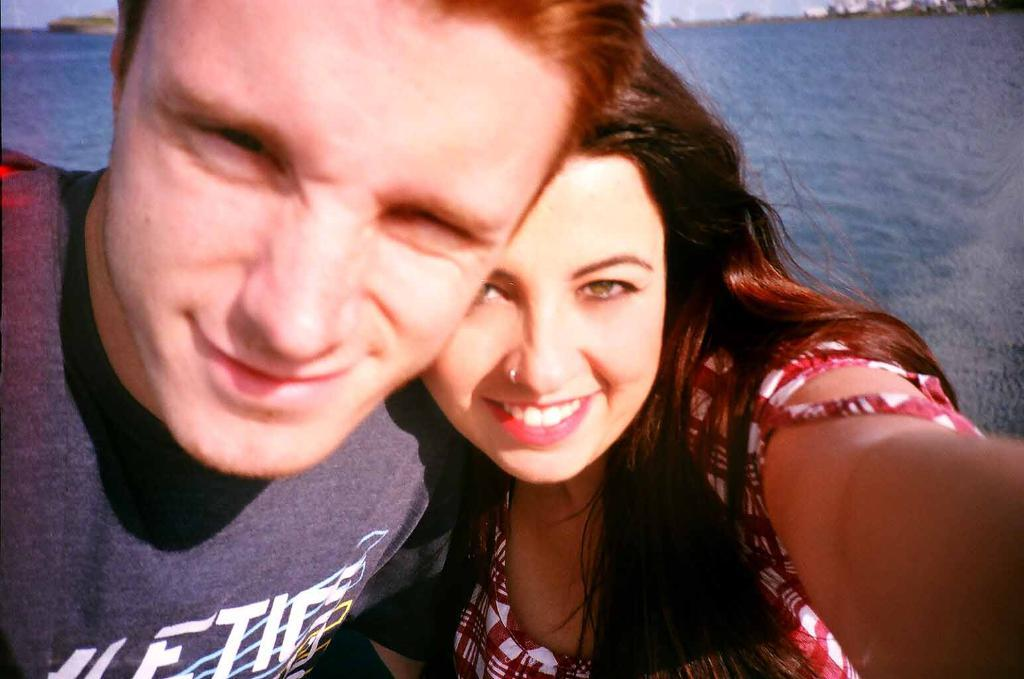How many people are in the image? There are two people in the image. What is the facial expression of the people in the image? The people are smiling. What can be seen in the background of the image? There is water and a boat visible in the background of the image. What type of juice is being served at the birthday party in the image? There is no birthday party or juice present in the image. 